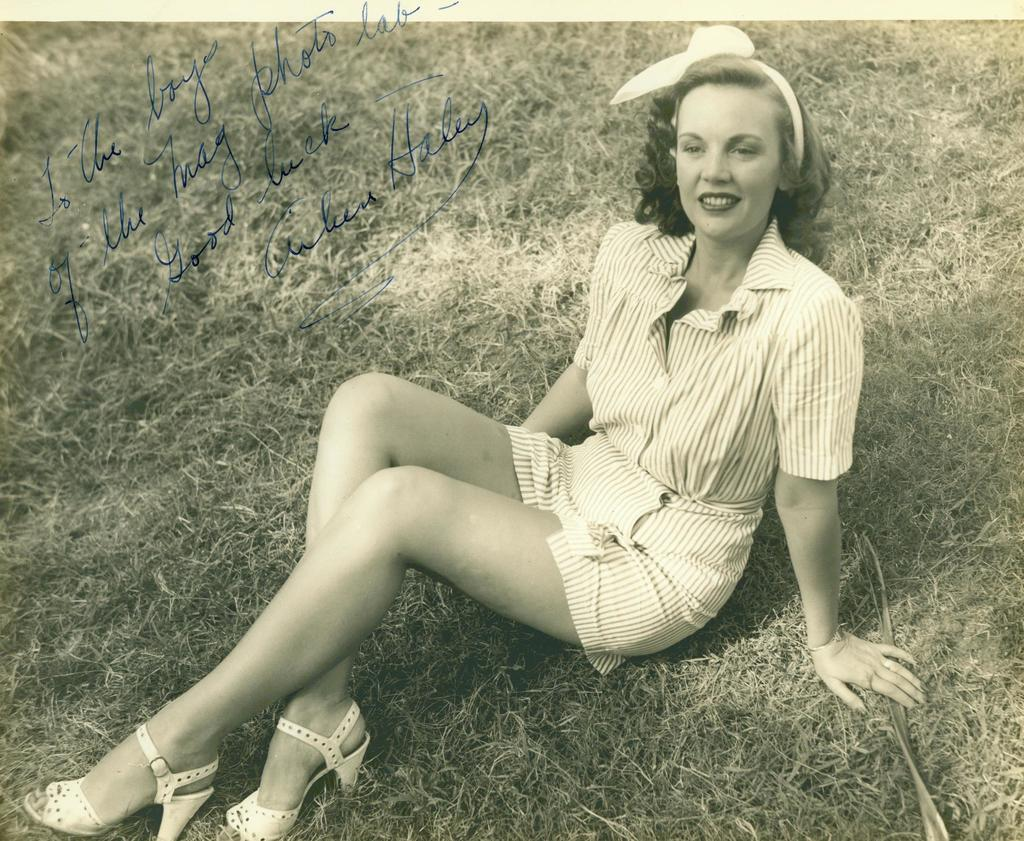Who is the main subject in the image? There is a lady in the image. What is the lady doing in the image? The lady is sitting on the grass. Where is the lady located in the image? The lady is in the center of the image. What type of bone can be seen in the lady's hand in the image? There is no bone visible in the lady's hand in the image. What appliance is the lady using while sitting on the grass? There is no appliance present in the image; the lady is simply sitting on the grass. 